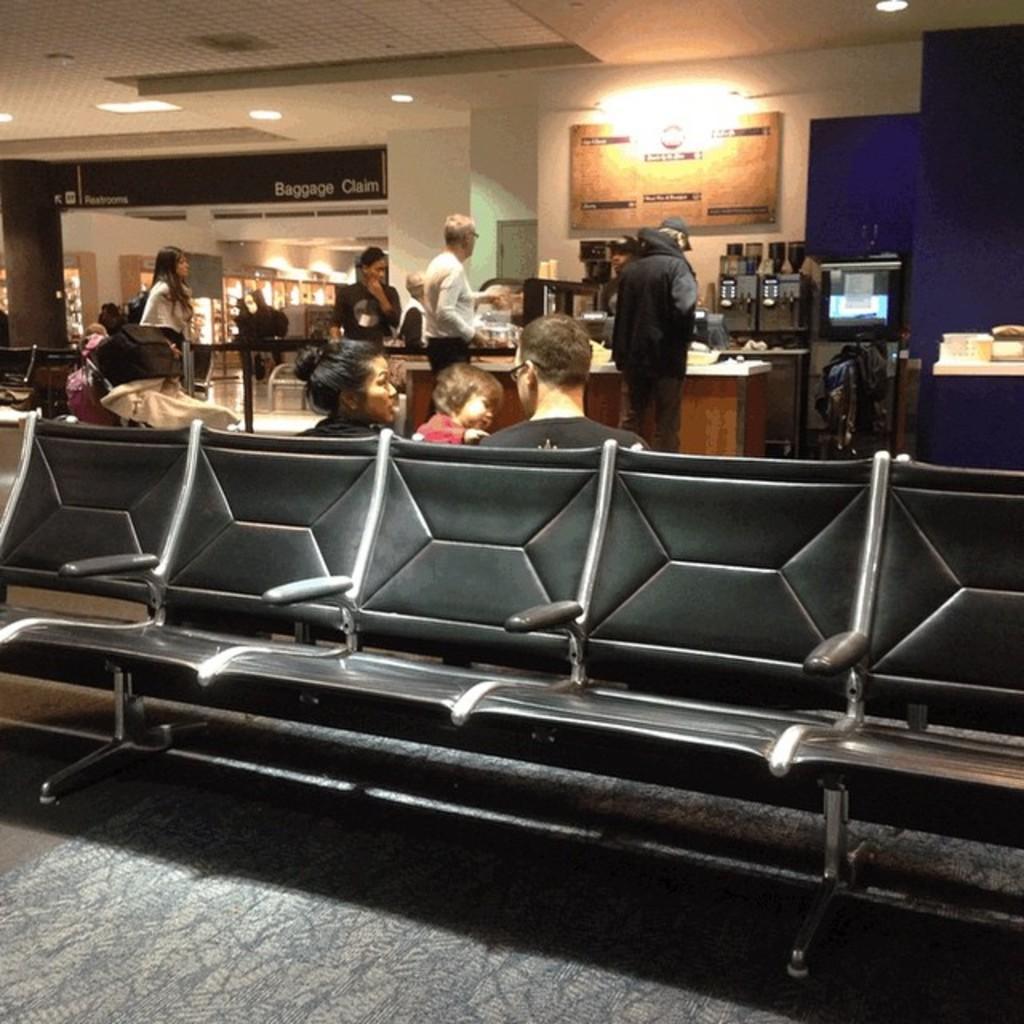Please provide a concise description of this image. Few persons are sitting on a chair and few persons are standing. On top there is a light. On this table there are machines. 